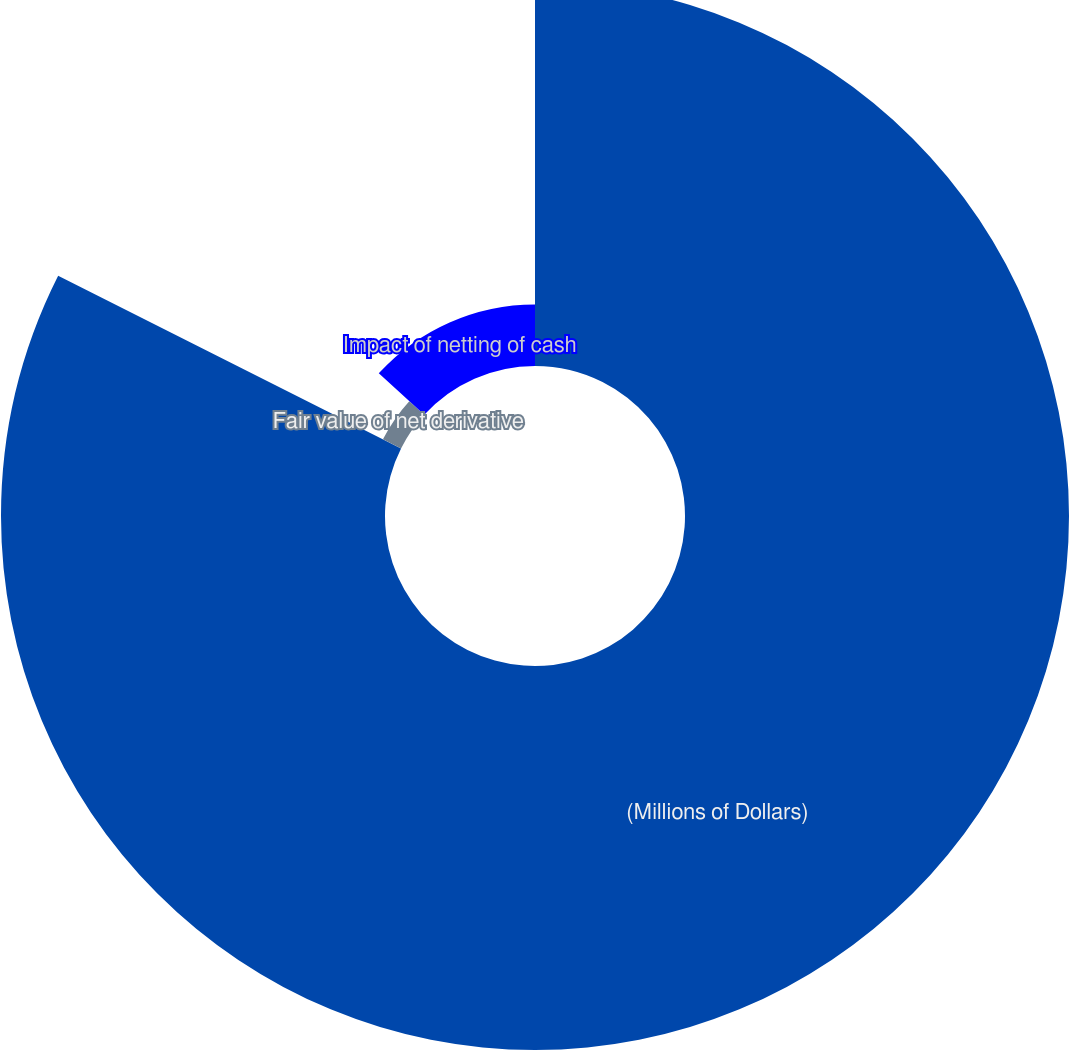Convert chart. <chart><loc_0><loc_0><loc_500><loc_500><pie_chart><fcel>(Millions of Dollars)<fcel>Fair value of net derivative<fcel>Impact of netting of cash<nl><fcel>82.43%<fcel>4.35%<fcel>13.22%<nl></chart> 